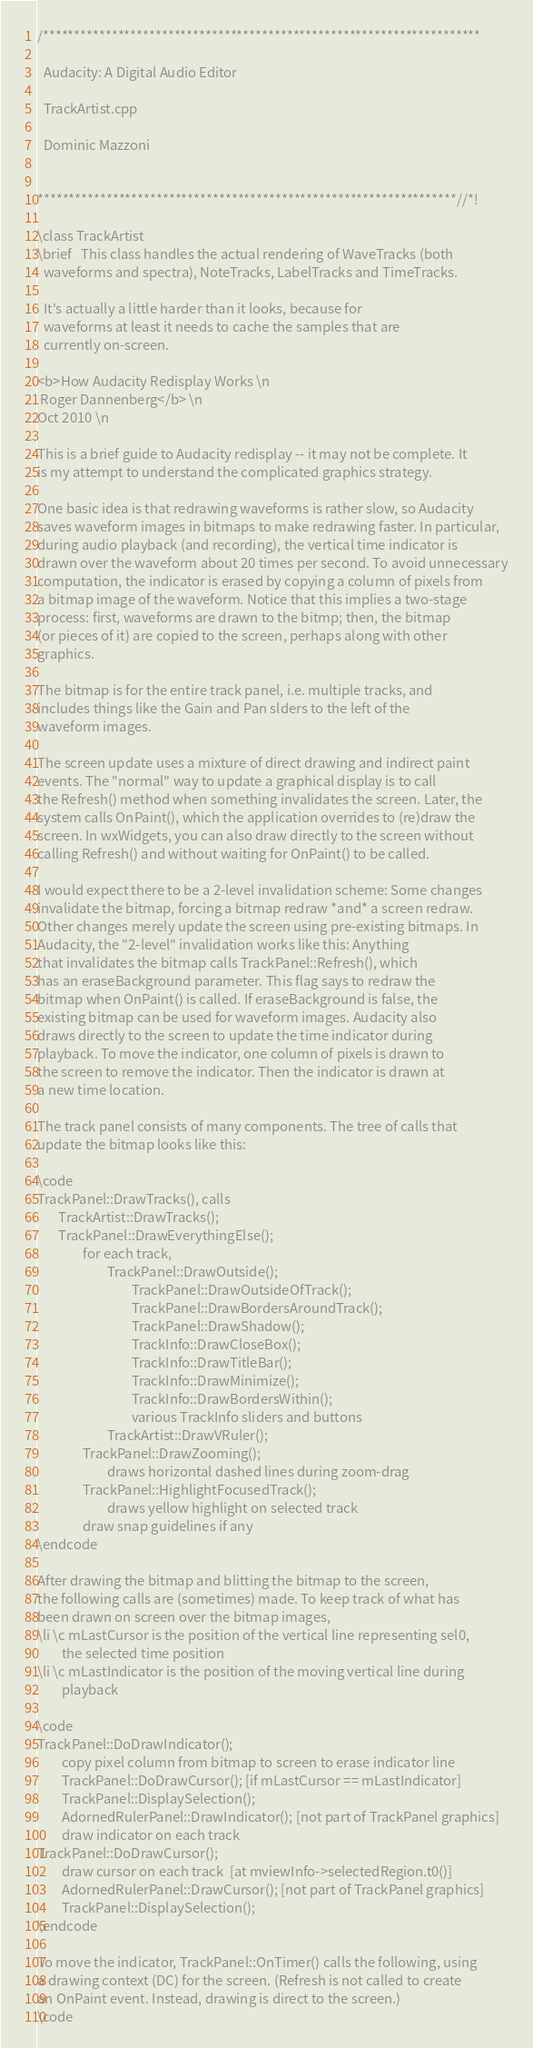Convert code to text. <code><loc_0><loc_0><loc_500><loc_500><_C++_>/**********************************************************************

  Audacity: A Digital Audio Editor

  TrackArtist.cpp

  Dominic Mazzoni


*******************************************************************//*!

\class TrackArtist
\brief   This class handles the actual rendering of WaveTracks (both
  waveforms and spectra), NoteTracks, LabelTracks and TimeTracks.

  It's actually a little harder than it looks, because for
  waveforms at least it needs to cache the samples that are
  currently on-screen.

<b>How Audacity Redisplay Works \n
 Roger Dannenberg</b> \n
Oct 2010 \n

This is a brief guide to Audacity redisplay -- it may not be complete. It
is my attempt to understand the complicated graphics strategy.

One basic idea is that redrawing waveforms is rather slow, so Audacity
saves waveform images in bitmaps to make redrawing faster. In particular,
during audio playback (and recording), the vertical time indicator is
drawn over the waveform about 20 times per second. To avoid unnecessary
computation, the indicator is erased by copying a column of pixels from
a bitmap image of the waveform. Notice that this implies a two-stage
process: first, waveforms are drawn to the bitmp; then, the bitmap
(or pieces of it) are copied to the screen, perhaps along with other
graphics.

The bitmap is for the entire track panel, i.e. multiple tracks, and
includes things like the Gain and Pan slders to the left of the
waveform images.

The screen update uses a mixture of direct drawing and indirect paint
events. The "normal" way to update a graphical display is to call
the Refresh() method when something invalidates the screen. Later, the
system calls OnPaint(), which the application overrides to (re)draw the
screen. In wxWidgets, you can also draw directly to the screen without
calling Refresh() and without waiting for OnPaint() to be called.

I would expect there to be a 2-level invalidation scheme: Some changes
invalidate the bitmap, forcing a bitmap redraw *and* a screen redraw.
Other changes merely update the screen using pre-existing bitmaps. In
Audacity, the "2-level" invalidation works like this: Anything
that invalidates the bitmap calls TrackPanel::Refresh(), which
has an eraseBackground parameter. This flag says to redraw the
bitmap when OnPaint() is called. If eraseBackground is false, the
existing bitmap can be used for waveform images. Audacity also
draws directly to the screen to update the time indicator during
playback. To move the indicator, one column of pixels is drawn to
the screen to remove the indicator. Then the indicator is drawn at
a new time location.

The track panel consists of many components. The tree of calls that
update the bitmap looks like this:

\code
TrackPanel::DrawTracks(), calls
       TrackArtist::DrawTracks();
       TrackPanel::DrawEverythingElse();
               for each track,
                       TrackPanel::DrawOutside();
                               TrackPanel::DrawOutsideOfTrack();
                               TrackPanel::DrawBordersAroundTrack();
                               TrackPanel::DrawShadow();
                               TrackInfo::DrawCloseBox();
                               TrackInfo::DrawTitleBar();
                               TrackInfo::DrawMinimize();
                               TrackInfo::DrawBordersWithin();
                               various TrackInfo sliders and buttons
                       TrackArtist::DrawVRuler();
               TrackPanel::DrawZooming();
                       draws horizontal dashed lines during zoom-drag
               TrackPanel::HighlightFocusedTrack();
                       draws yellow highlight on selected track
               draw snap guidelines if any
\endcode

After drawing the bitmap and blitting the bitmap to the screen,
the following calls are (sometimes) made. To keep track of what has
been drawn on screen over the bitmap images,
\li \c mLastCursor is the position of the vertical line representing sel0,
        the selected time position
\li \c mLastIndicator is the position of the moving vertical line during
        playback

\code
TrackPanel::DoDrawIndicator();
        copy pixel column from bitmap to screen to erase indicator line
        TrackPanel::DoDrawCursor(); [if mLastCursor == mLastIndicator]
        TrackPanel::DisplaySelection();
        AdornedRulerPanel::DrawIndicator(); [not part of TrackPanel graphics]
        draw indicator on each track
TrackPanel::DoDrawCursor();
        draw cursor on each track  [at mviewInfo->selectedRegion.t0()]
        AdornedRulerPanel::DrawCursor(); [not part of TrackPanel graphics]
        TrackPanel::DisplaySelection();
\endcode

To move the indicator, TrackPanel::OnTimer() calls the following, using
a drawing context (DC) for the screen. (Refresh is not called to create
an OnPaint event. Instead, drawing is direct to the screen.)
\code</code> 